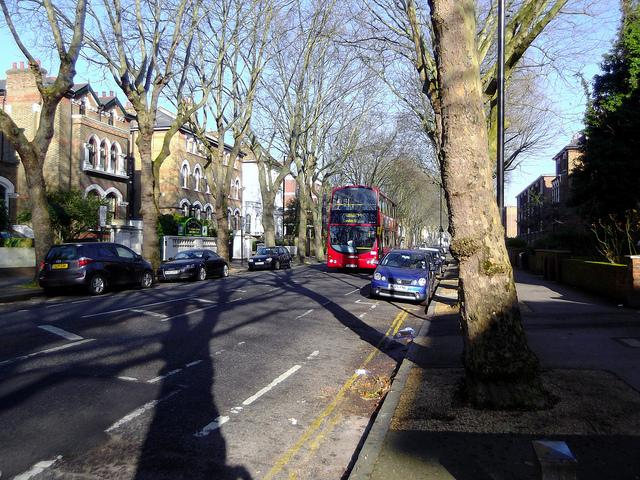Why are the cars lined up along the curb? Please explain your reasoning. to park. Cars are lined up on a street. people park on the side of the street. 